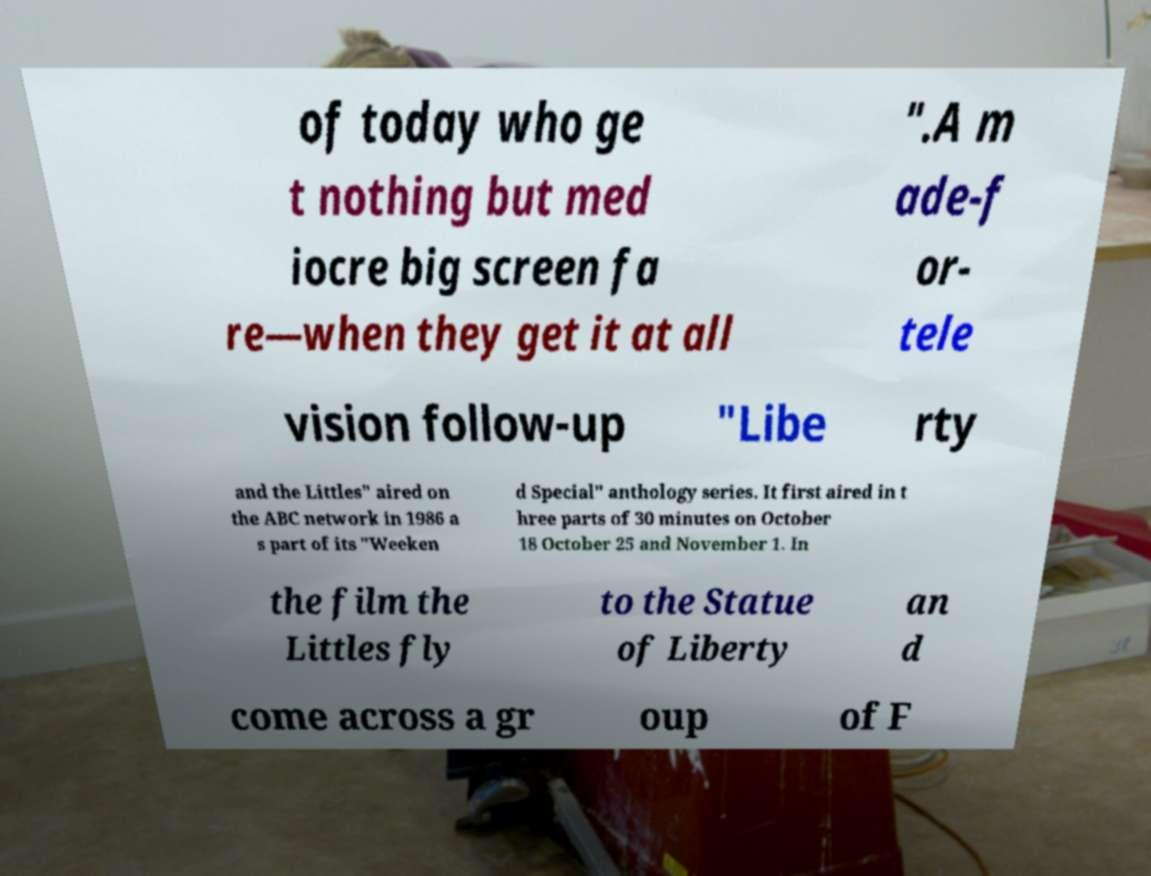Could you extract and type out the text from this image? of today who ge t nothing but med iocre big screen fa re—when they get it at all ".A m ade-f or- tele vision follow-up "Libe rty and the Littles" aired on the ABC network in 1986 a s part of its "Weeken d Special" anthology series. It first aired in t hree parts of 30 minutes on October 18 October 25 and November 1. In the film the Littles fly to the Statue of Liberty an d come across a gr oup of F 